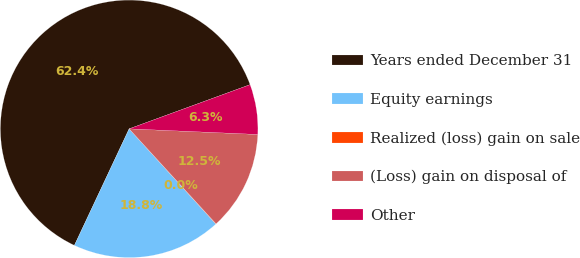Convert chart to OTSL. <chart><loc_0><loc_0><loc_500><loc_500><pie_chart><fcel>Years ended December 31<fcel>Equity earnings<fcel>Realized (loss) gain on sale<fcel>(Loss) gain on disposal of<fcel>Other<nl><fcel>62.43%<fcel>18.75%<fcel>0.03%<fcel>12.51%<fcel>6.27%<nl></chart> 